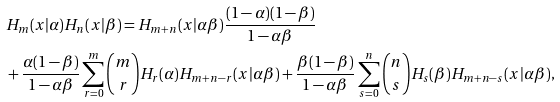<formula> <loc_0><loc_0><loc_500><loc_500>& H _ { m } ( x | \alpha ) H _ { n } ( x | \beta ) = H _ { m + n } ( x | \alpha \beta ) \frac { ( 1 - \alpha ) ( 1 - \beta ) } { 1 - \alpha \beta } \\ & + \frac { \alpha ( 1 - \beta ) } { 1 - \alpha \beta } \sum _ { r = 0 } ^ { m } \binom { m } { r } H _ { r } ( \alpha ) H _ { m + n - r } ( x | \alpha \beta ) + \frac { \beta ( 1 - \beta ) } { 1 - \alpha \beta } \sum _ { s = 0 } ^ { n } \binom { n } { s } H _ { s } ( \beta ) H _ { m + n - s } ( x | \alpha \beta ) ,</formula> 